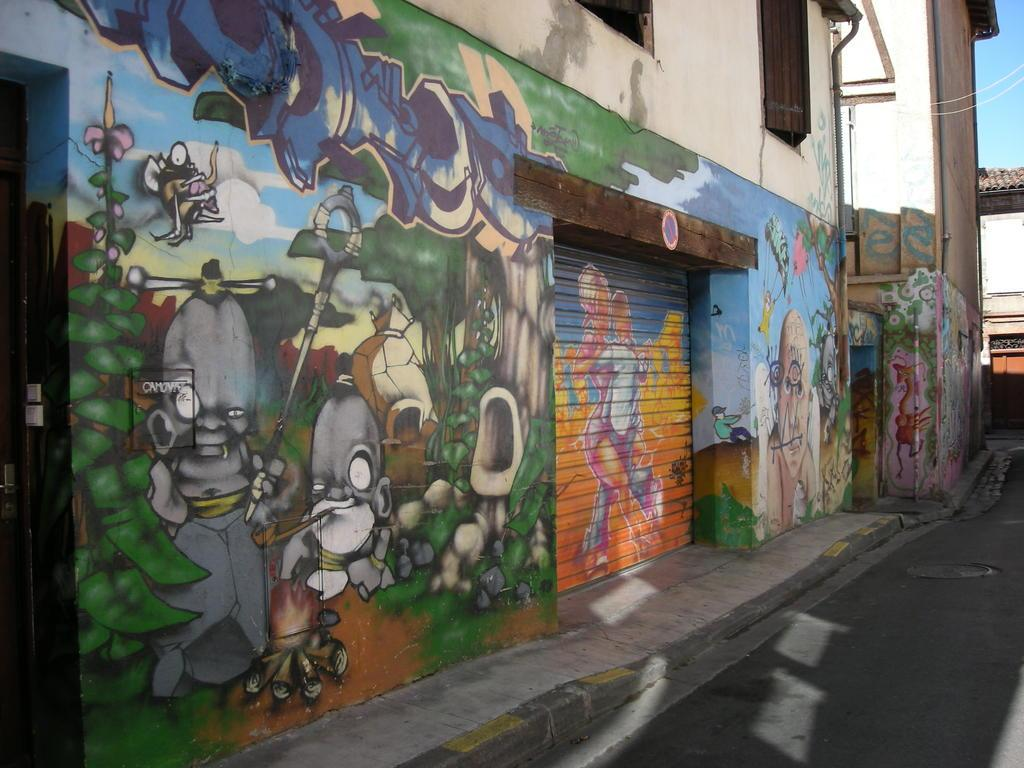What type of structures are present in the image? There are buildings in the image. What can be seen on the buildings? There is painting on the buildings. What part of the natural environment is visible in the image? The sky is visible in the top right corner of the image. Where is the playground located in the image? There is no playground present in the image. What type of wool is used in the painting on the buildings? There is no wool mentioned or visible in the painting on the buildings. 